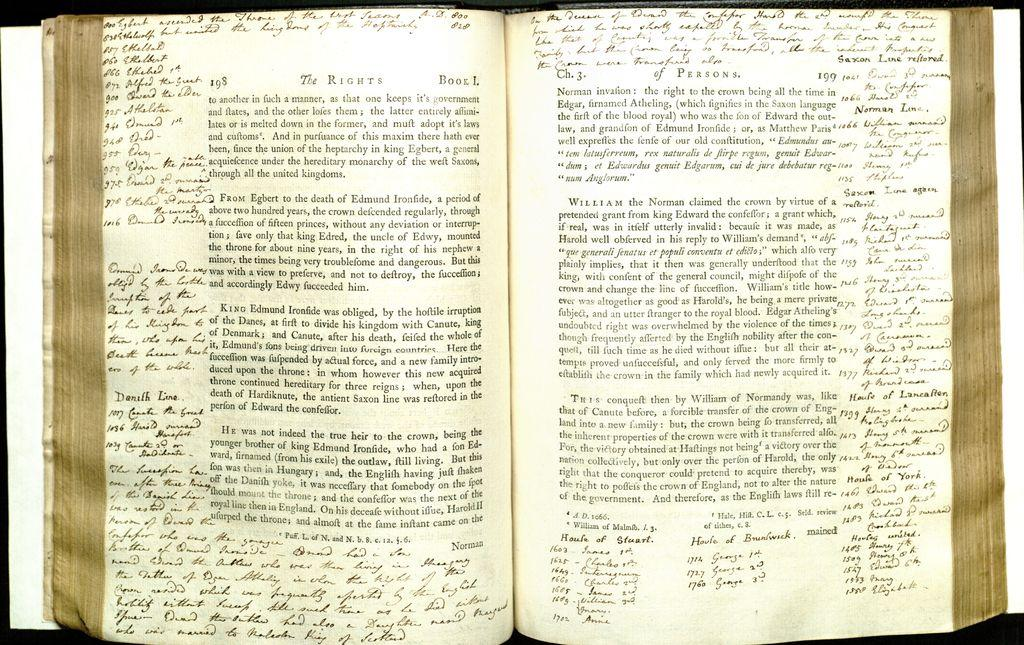What is depicted on the pages in the image? There are pages of a book in the image, and something is written on them. What is the color of the pages? The color of the pages is white. How do the children react to the window in the image? There are no children or window present in the image; it only features pages of a book with writing on them. 